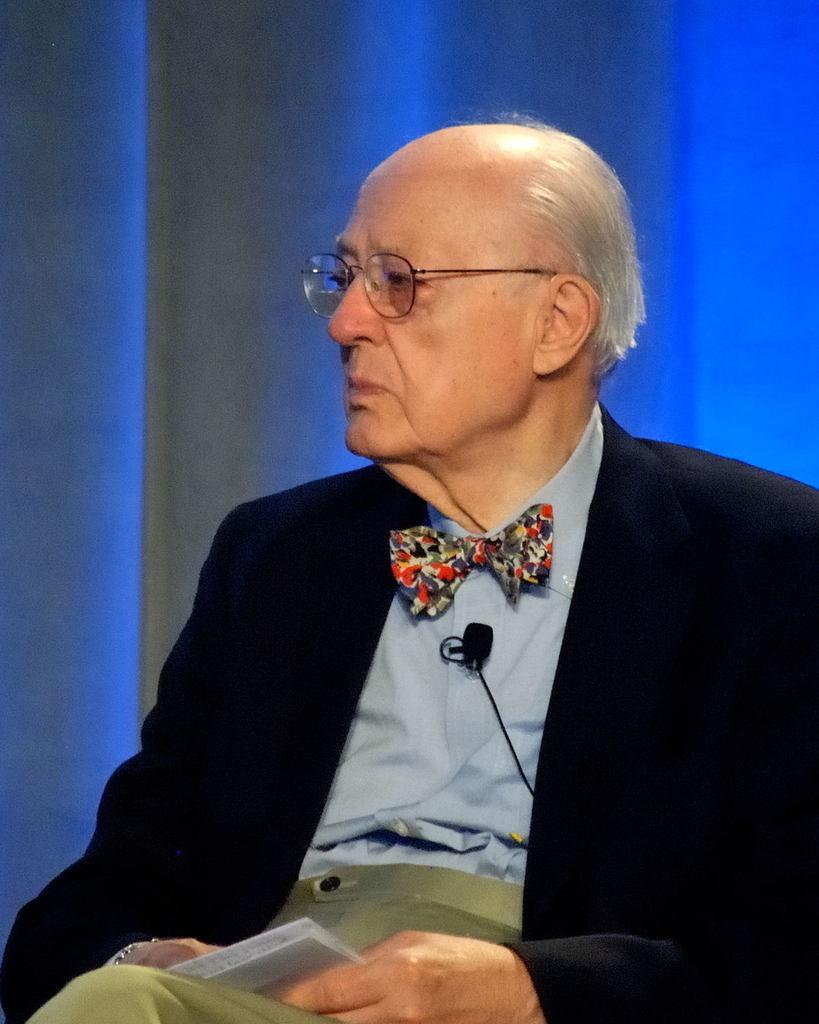How would you summarize this image in a sentence or two? In this image I can see a man is sitting and I can see he is holding a white colour thing. I can also see he is wearing black blazer, a bow tie, shirt, pant and a specs. I can also see a mic on his chest and in the background I can see blue colour. 